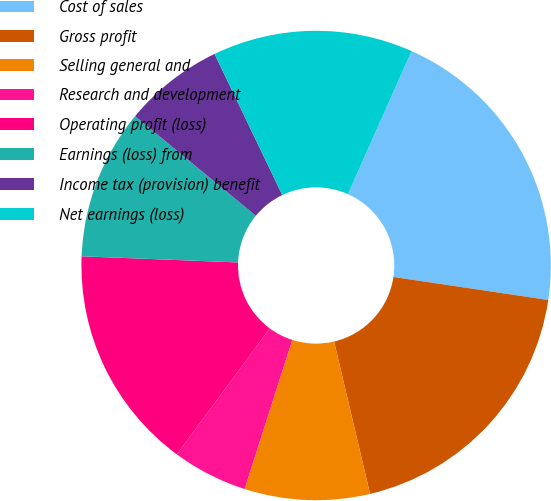Convert chart. <chart><loc_0><loc_0><loc_500><loc_500><pie_chart><fcel>Cost of sales<fcel>Gross profit<fcel>Selling general and<fcel>Research and development<fcel>Operating profit (loss)<fcel>Earnings (loss) from<fcel>Income tax (provision) benefit<fcel>Net earnings (loss)<nl><fcel>20.68%<fcel>18.96%<fcel>8.62%<fcel>5.18%<fcel>15.51%<fcel>10.35%<fcel>6.9%<fcel>13.79%<nl></chart> 